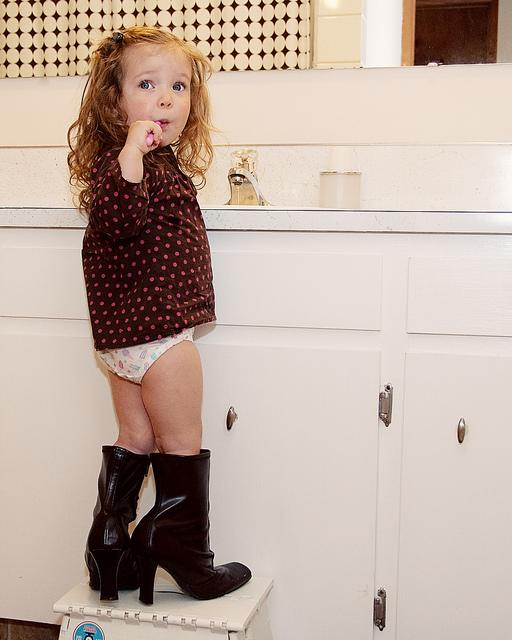Which piece of attire is abnormal for the child to wear? boots 